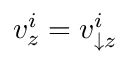<formula> <loc_0><loc_0><loc_500><loc_500>v _ { z } ^ { i } = v _ { \downarrow z } ^ { i }</formula> 